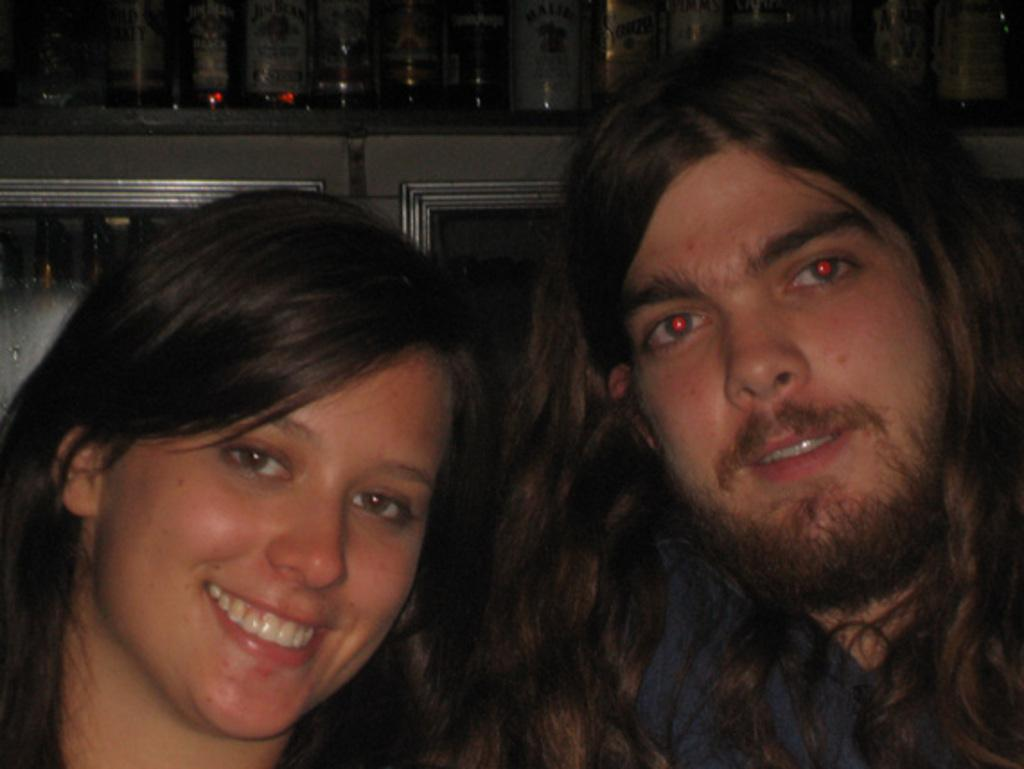How many people are in the image? There are two persons in the image. What expression do the persons have? The persons are smiling. What can be seen in the background of the image? There are bottles on a cupboard in the background. Can you describe the contents of the cupboard in the background? There are bottles inside the cupboard in the background. What type of vein is visible on the person's forehead in the image? There is no visible vein on the person's forehead in the image. How many beads are present on the person's necklace in the image? There is no necklace or beads present in the image. 